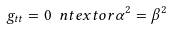Convert formula to latex. <formula><loc_0><loc_0><loc_500><loc_500>g _ { t t } = 0 \ n t e x t { o r } \alpha ^ { 2 } = \beta ^ { 2 }</formula> 